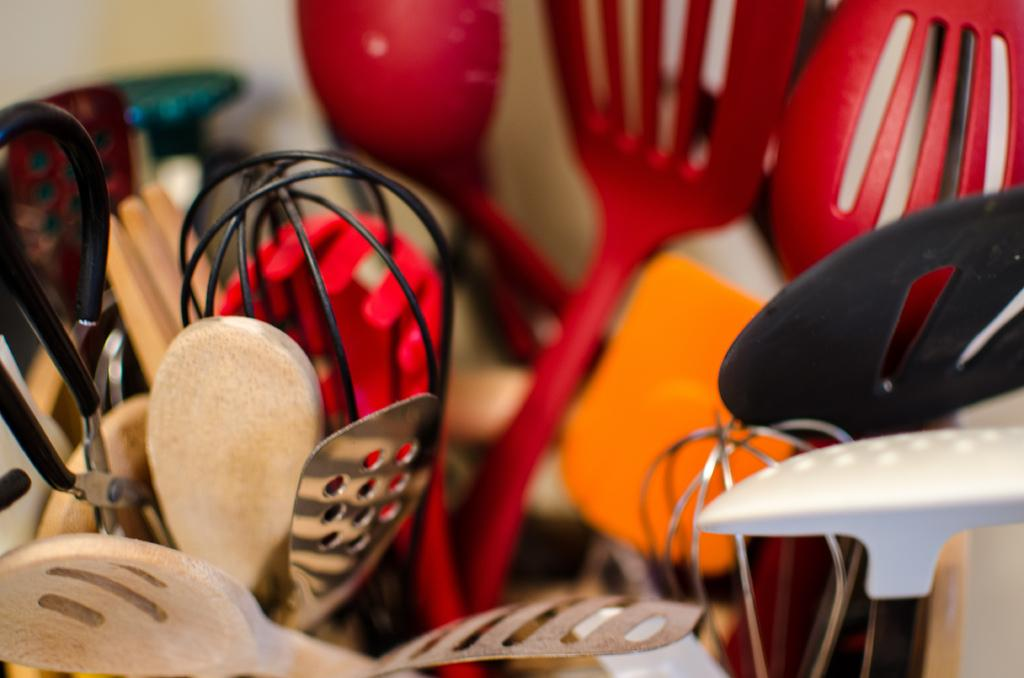What type of utensils can be seen in the picture? There are spoons in the picture. How many different types of spoons are present? The spoons come in different models. What materials are the spoons made of? The spoons are made of different materials, including wood, steel, plastic, and fiber. Can you tell me how many zebras are visible in the picture? There are no zebras present in the picture; it features spoons made of different materials. 